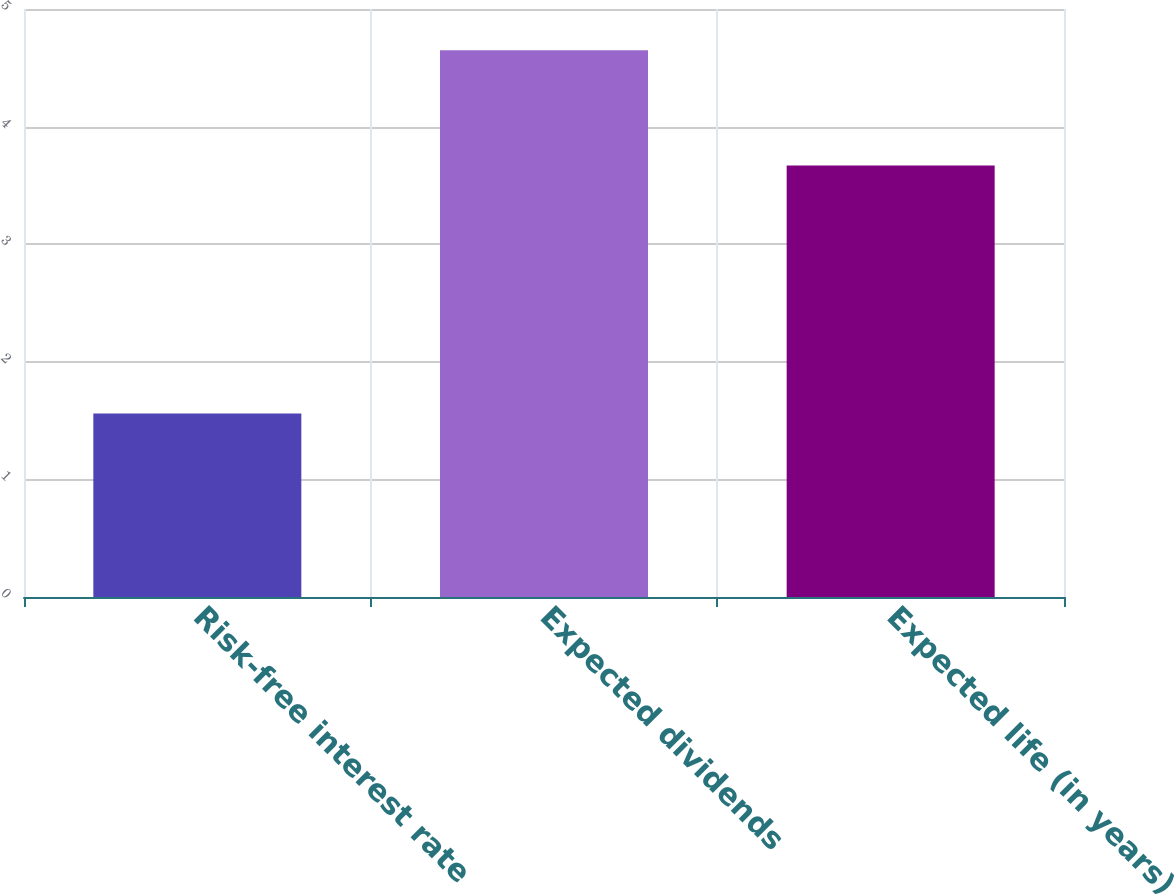Convert chart. <chart><loc_0><loc_0><loc_500><loc_500><bar_chart><fcel>Risk-free interest rate<fcel>Expected dividends<fcel>Expected life (in years)<nl><fcel>1.56<fcel>4.65<fcel>3.67<nl></chart> 